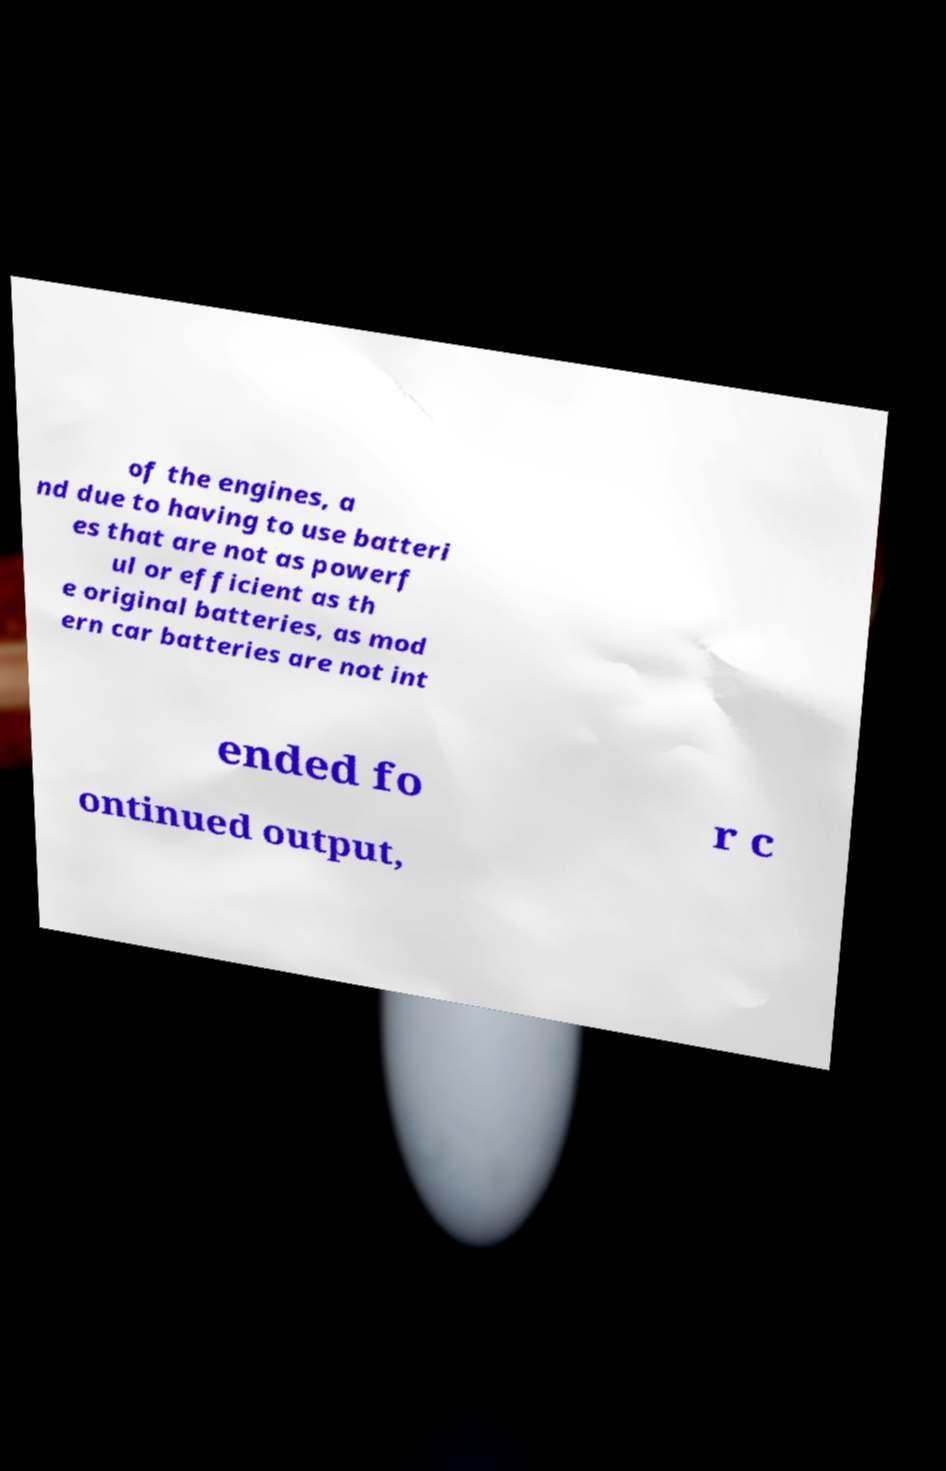Can you read and provide the text displayed in the image?This photo seems to have some interesting text. Can you extract and type it out for me? of the engines, a nd due to having to use batteri es that are not as powerf ul or efficient as th e original batteries, as mod ern car batteries are not int ended fo r c ontinued output, 